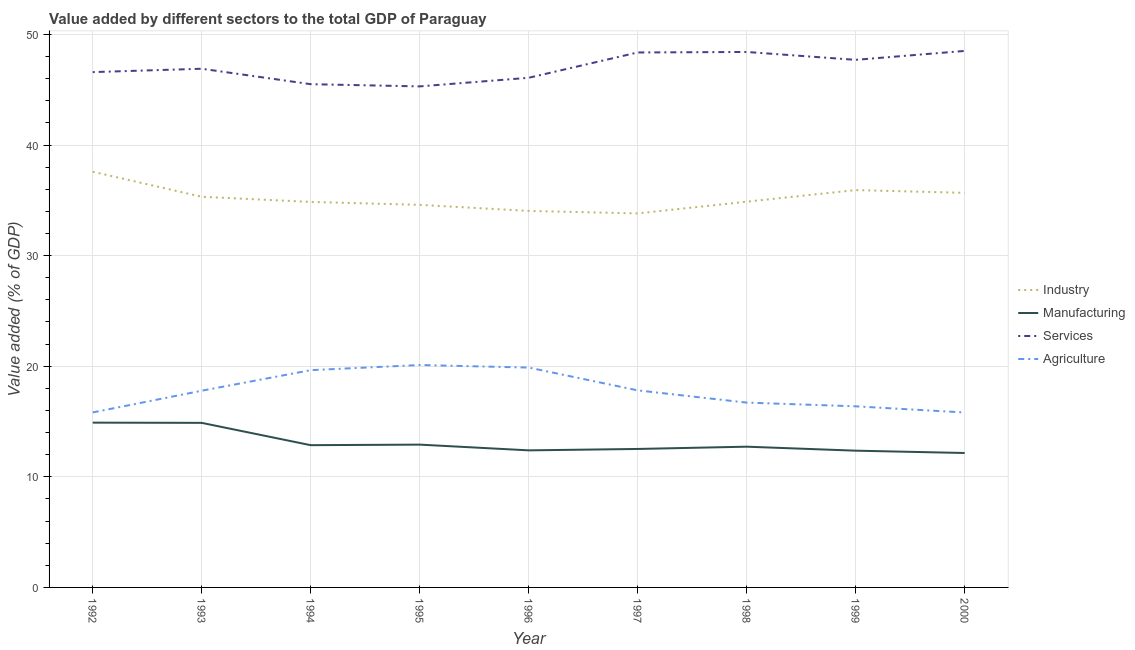How many different coloured lines are there?
Give a very brief answer. 4. What is the value added by manufacturing sector in 1997?
Your response must be concise. 12.52. Across all years, what is the maximum value added by industrial sector?
Offer a terse response. 37.59. Across all years, what is the minimum value added by agricultural sector?
Keep it short and to the point. 15.82. What is the total value added by industrial sector in the graph?
Keep it short and to the point. 316.69. What is the difference between the value added by services sector in 1992 and that in 1997?
Keep it short and to the point. -1.78. What is the difference between the value added by agricultural sector in 1998 and the value added by industrial sector in 1994?
Provide a short and direct response. -18.15. What is the average value added by industrial sector per year?
Ensure brevity in your answer.  35.19. In the year 1999, what is the difference between the value added by industrial sector and value added by agricultural sector?
Make the answer very short. 19.55. What is the ratio of the value added by manufacturing sector in 1992 to that in 1999?
Your answer should be compact. 1.21. Is the value added by services sector in 1992 less than that in 1996?
Offer a terse response. No. Is the difference between the value added by agricultural sector in 1993 and 1995 greater than the difference between the value added by industrial sector in 1993 and 1995?
Offer a very short reply. No. What is the difference between the highest and the second highest value added by industrial sector?
Give a very brief answer. 1.66. What is the difference between the highest and the lowest value added by industrial sector?
Keep it short and to the point. 3.77. Does the value added by manufacturing sector monotonically increase over the years?
Make the answer very short. No. Is the value added by services sector strictly greater than the value added by industrial sector over the years?
Keep it short and to the point. Yes. Is the value added by services sector strictly less than the value added by agricultural sector over the years?
Give a very brief answer. No. What is the difference between two consecutive major ticks on the Y-axis?
Your response must be concise. 10. Does the graph contain any zero values?
Your response must be concise. No. How many legend labels are there?
Provide a succinct answer. 4. What is the title of the graph?
Keep it short and to the point. Value added by different sectors to the total GDP of Paraguay. Does "Offering training" appear as one of the legend labels in the graph?
Keep it short and to the point. No. What is the label or title of the Y-axis?
Provide a succinct answer. Value added (% of GDP). What is the Value added (% of GDP) of Industry in 1992?
Offer a very short reply. 37.59. What is the Value added (% of GDP) of Manufacturing in 1992?
Offer a terse response. 14.9. What is the Value added (% of GDP) in Services in 1992?
Provide a short and direct response. 46.59. What is the Value added (% of GDP) in Agriculture in 1992?
Your answer should be compact. 15.82. What is the Value added (% of GDP) of Industry in 1993?
Provide a short and direct response. 35.32. What is the Value added (% of GDP) in Manufacturing in 1993?
Offer a very short reply. 14.88. What is the Value added (% of GDP) in Services in 1993?
Provide a short and direct response. 46.9. What is the Value added (% of GDP) in Agriculture in 1993?
Your response must be concise. 17.78. What is the Value added (% of GDP) of Industry in 1994?
Ensure brevity in your answer.  34.86. What is the Value added (% of GDP) in Manufacturing in 1994?
Provide a succinct answer. 12.86. What is the Value added (% of GDP) in Services in 1994?
Your answer should be very brief. 45.5. What is the Value added (% of GDP) in Agriculture in 1994?
Offer a very short reply. 19.64. What is the Value added (% of GDP) of Industry in 1995?
Ensure brevity in your answer.  34.59. What is the Value added (% of GDP) in Manufacturing in 1995?
Your response must be concise. 12.91. What is the Value added (% of GDP) in Services in 1995?
Provide a short and direct response. 45.3. What is the Value added (% of GDP) in Agriculture in 1995?
Your answer should be compact. 20.11. What is the Value added (% of GDP) of Industry in 1996?
Ensure brevity in your answer.  34.04. What is the Value added (% of GDP) of Manufacturing in 1996?
Your response must be concise. 12.39. What is the Value added (% of GDP) in Services in 1996?
Keep it short and to the point. 46.08. What is the Value added (% of GDP) in Agriculture in 1996?
Keep it short and to the point. 19.88. What is the Value added (% of GDP) of Industry in 1997?
Your answer should be compact. 33.82. What is the Value added (% of GDP) in Manufacturing in 1997?
Offer a very short reply. 12.52. What is the Value added (% of GDP) in Services in 1997?
Keep it short and to the point. 48.37. What is the Value added (% of GDP) of Agriculture in 1997?
Ensure brevity in your answer.  17.82. What is the Value added (% of GDP) in Industry in 1998?
Keep it short and to the point. 34.88. What is the Value added (% of GDP) of Manufacturing in 1998?
Your answer should be compact. 12.72. What is the Value added (% of GDP) of Services in 1998?
Provide a short and direct response. 48.41. What is the Value added (% of GDP) of Agriculture in 1998?
Your answer should be very brief. 16.71. What is the Value added (% of GDP) in Industry in 1999?
Provide a succinct answer. 35.93. What is the Value added (% of GDP) of Manufacturing in 1999?
Your response must be concise. 12.36. What is the Value added (% of GDP) in Services in 1999?
Your response must be concise. 47.7. What is the Value added (% of GDP) of Agriculture in 1999?
Provide a short and direct response. 16.37. What is the Value added (% of GDP) of Industry in 2000?
Offer a very short reply. 35.68. What is the Value added (% of GDP) of Manufacturing in 2000?
Offer a very short reply. 12.15. What is the Value added (% of GDP) in Services in 2000?
Provide a short and direct response. 48.51. What is the Value added (% of GDP) of Agriculture in 2000?
Your response must be concise. 15.82. Across all years, what is the maximum Value added (% of GDP) in Industry?
Your answer should be very brief. 37.59. Across all years, what is the maximum Value added (% of GDP) of Manufacturing?
Ensure brevity in your answer.  14.9. Across all years, what is the maximum Value added (% of GDP) in Services?
Provide a succinct answer. 48.51. Across all years, what is the maximum Value added (% of GDP) in Agriculture?
Make the answer very short. 20.11. Across all years, what is the minimum Value added (% of GDP) of Industry?
Provide a succinct answer. 33.82. Across all years, what is the minimum Value added (% of GDP) of Manufacturing?
Offer a very short reply. 12.15. Across all years, what is the minimum Value added (% of GDP) in Services?
Give a very brief answer. 45.3. Across all years, what is the minimum Value added (% of GDP) of Agriculture?
Keep it short and to the point. 15.82. What is the total Value added (% of GDP) of Industry in the graph?
Give a very brief answer. 316.69. What is the total Value added (% of GDP) in Manufacturing in the graph?
Keep it short and to the point. 117.71. What is the total Value added (% of GDP) of Services in the graph?
Keep it short and to the point. 423.35. What is the total Value added (% of GDP) of Agriculture in the graph?
Offer a very short reply. 159.96. What is the difference between the Value added (% of GDP) in Industry in 1992 and that in 1993?
Ensure brevity in your answer.  2.27. What is the difference between the Value added (% of GDP) of Manufacturing in 1992 and that in 1993?
Your answer should be very brief. 0.02. What is the difference between the Value added (% of GDP) in Services in 1992 and that in 1993?
Ensure brevity in your answer.  -0.3. What is the difference between the Value added (% of GDP) of Agriculture in 1992 and that in 1993?
Offer a very short reply. -1.96. What is the difference between the Value added (% of GDP) of Industry in 1992 and that in 1994?
Your answer should be very brief. 2.73. What is the difference between the Value added (% of GDP) in Manufacturing in 1992 and that in 1994?
Make the answer very short. 2.04. What is the difference between the Value added (% of GDP) in Services in 1992 and that in 1994?
Ensure brevity in your answer.  1.09. What is the difference between the Value added (% of GDP) in Agriculture in 1992 and that in 1994?
Give a very brief answer. -3.82. What is the difference between the Value added (% of GDP) in Industry in 1992 and that in 1995?
Your answer should be very brief. 3. What is the difference between the Value added (% of GDP) of Manufacturing in 1992 and that in 1995?
Offer a terse response. 1.99. What is the difference between the Value added (% of GDP) of Services in 1992 and that in 1995?
Ensure brevity in your answer.  1.29. What is the difference between the Value added (% of GDP) in Agriculture in 1992 and that in 1995?
Keep it short and to the point. -4.29. What is the difference between the Value added (% of GDP) of Industry in 1992 and that in 1996?
Your answer should be compact. 3.54. What is the difference between the Value added (% of GDP) in Manufacturing in 1992 and that in 1996?
Provide a short and direct response. 2.51. What is the difference between the Value added (% of GDP) in Services in 1992 and that in 1996?
Offer a terse response. 0.51. What is the difference between the Value added (% of GDP) in Agriculture in 1992 and that in 1996?
Your response must be concise. -4.06. What is the difference between the Value added (% of GDP) in Industry in 1992 and that in 1997?
Ensure brevity in your answer.  3.77. What is the difference between the Value added (% of GDP) in Manufacturing in 1992 and that in 1997?
Offer a very short reply. 2.38. What is the difference between the Value added (% of GDP) in Services in 1992 and that in 1997?
Provide a short and direct response. -1.78. What is the difference between the Value added (% of GDP) of Agriculture in 1992 and that in 1997?
Your response must be concise. -1.99. What is the difference between the Value added (% of GDP) of Industry in 1992 and that in 1998?
Offer a very short reply. 2.71. What is the difference between the Value added (% of GDP) in Manufacturing in 1992 and that in 1998?
Offer a very short reply. 2.18. What is the difference between the Value added (% of GDP) of Services in 1992 and that in 1998?
Keep it short and to the point. -1.82. What is the difference between the Value added (% of GDP) in Agriculture in 1992 and that in 1998?
Provide a short and direct response. -0.89. What is the difference between the Value added (% of GDP) of Industry in 1992 and that in 1999?
Offer a very short reply. 1.66. What is the difference between the Value added (% of GDP) of Manufacturing in 1992 and that in 1999?
Make the answer very short. 2.54. What is the difference between the Value added (% of GDP) in Services in 1992 and that in 1999?
Ensure brevity in your answer.  -1.11. What is the difference between the Value added (% of GDP) of Agriculture in 1992 and that in 1999?
Make the answer very short. -0.55. What is the difference between the Value added (% of GDP) in Industry in 1992 and that in 2000?
Offer a terse response. 1.91. What is the difference between the Value added (% of GDP) in Manufacturing in 1992 and that in 2000?
Your answer should be very brief. 2.75. What is the difference between the Value added (% of GDP) in Services in 1992 and that in 2000?
Your answer should be compact. -1.92. What is the difference between the Value added (% of GDP) of Agriculture in 1992 and that in 2000?
Make the answer very short. 0.01. What is the difference between the Value added (% of GDP) in Industry in 1993 and that in 1994?
Your answer should be compact. 0.46. What is the difference between the Value added (% of GDP) in Manufacturing in 1993 and that in 1994?
Provide a short and direct response. 2.02. What is the difference between the Value added (% of GDP) in Services in 1993 and that in 1994?
Your answer should be compact. 1.4. What is the difference between the Value added (% of GDP) in Agriculture in 1993 and that in 1994?
Make the answer very short. -1.86. What is the difference between the Value added (% of GDP) in Industry in 1993 and that in 1995?
Provide a succinct answer. 0.73. What is the difference between the Value added (% of GDP) of Manufacturing in 1993 and that in 1995?
Offer a very short reply. 1.97. What is the difference between the Value added (% of GDP) in Services in 1993 and that in 1995?
Offer a very short reply. 1.6. What is the difference between the Value added (% of GDP) of Agriculture in 1993 and that in 1995?
Your answer should be compact. -2.33. What is the difference between the Value added (% of GDP) in Industry in 1993 and that in 1996?
Your answer should be very brief. 1.28. What is the difference between the Value added (% of GDP) in Manufacturing in 1993 and that in 1996?
Offer a terse response. 2.49. What is the difference between the Value added (% of GDP) in Services in 1993 and that in 1996?
Offer a terse response. 0.82. What is the difference between the Value added (% of GDP) in Agriculture in 1993 and that in 1996?
Provide a short and direct response. -2.09. What is the difference between the Value added (% of GDP) of Industry in 1993 and that in 1997?
Offer a terse response. 1.5. What is the difference between the Value added (% of GDP) of Manufacturing in 1993 and that in 1997?
Your response must be concise. 2.36. What is the difference between the Value added (% of GDP) of Services in 1993 and that in 1997?
Offer a very short reply. -1.47. What is the difference between the Value added (% of GDP) in Agriculture in 1993 and that in 1997?
Offer a terse response. -0.03. What is the difference between the Value added (% of GDP) of Industry in 1993 and that in 1998?
Keep it short and to the point. 0.44. What is the difference between the Value added (% of GDP) in Manufacturing in 1993 and that in 1998?
Provide a short and direct response. 2.15. What is the difference between the Value added (% of GDP) of Services in 1993 and that in 1998?
Provide a succinct answer. -1.52. What is the difference between the Value added (% of GDP) of Agriculture in 1993 and that in 1998?
Give a very brief answer. 1.07. What is the difference between the Value added (% of GDP) in Industry in 1993 and that in 1999?
Keep it short and to the point. -0.61. What is the difference between the Value added (% of GDP) of Manufacturing in 1993 and that in 1999?
Keep it short and to the point. 2.51. What is the difference between the Value added (% of GDP) in Services in 1993 and that in 1999?
Give a very brief answer. -0.8. What is the difference between the Value added (% of GDP) in Agriculture in 1993 and that in 1999?
Your answer should be compact. 1.41. What is the difference between the Value added (% of GDP) in Industry in 1993 and that in 2000?
Your answer should be very brief. -0.36. What is the difference between the Value added (% of GDP) in Manufacturing in 1993 and that in 2000?
Your response must be concise. 2.73. What is the difference between the Value added (% of GDP) in Services in 1993 and that in 2000?
Provide a succinct answer. -1.61. What is the difference between the Value added (% of GDP) in Agriculture in 1993 and that in 2000?
Keep it short and to the point. 1.97. What is the difference between the Value added (% of GDP) in Industry in 1994 and that in 1995?
Give a very brief answer. 0.27. What is the difference between the Value added (% of GDP) of Services in 1994 and that in 1995?
Make the answer very short. 0.2. What is the difference between the Value added (% of GDP) in Agriculture in 1994 and that in 1995?
Provide a succinct answer. -0.47. What is the difference between the Value added (% of GDP) of Industry in 1994 and that in 1996?
Your answer should be compact. 0.81. What is the difference between the Value added (% of GDP) of Manufacturing in 1994 and that in 1996?
Your response must be concise. 0.47. What is the difference between the Value added (% of GDP) of Services in 1994 and that in 1996?
Give a very brief answer. -0.58. What is the difference between the Value added (% of GDP) in Agriculture in 1994 and that in 1996?
Offer a very short reply. -0.24. What is the difference between the Value added (% of GDP) in Industry in 1994 and that in 1997?
Make the answer very short. 1.04. What is the difference between the Value added (% of GDP) of Manufacturing in 1994 and that in 1997?
Provide a short and direct response. 0.34. What is the difference between the Value added (% of GDP) in Services in 1994 and that in 1997?
Offer a very short reply. -2.87. What is the difference between the Value added (% of GDP) of Agriculture in 1994 and that in 1997?
Ensure brevity in your answer.  1.83. What is the difference between the Value added (% of GDP) of Industry in 1994 and that in 1998?
Provide a short and direct response. -0.02. What is the difference between the Value added (% of GDP) of Manufacturing in 1994 and that in 1998?
Make the answer very short. 0.14. What is the difference between the Value added (% of GDP) of Services in 1994 and that in 1998?
Ensure brevity in your answer.  -2.91. What is the difference between the Value added (% of GDP) in Agriculture in 1994 and that in 1998?
Offer a very short reply. 2.93. What is the difference between the Value added (% of GDP) of Industry in 1994 and that in 1999?
Offer a terse response. -1.07. What is the difference between the Value added (% of GDP) in Manufacturing in 1994 and that in 1999?
Offer a very short reply. 0.5. What is the difference between the Value added (% of GDP) of Services in 1994 and that in 1999?
Offer a very short reply. -2.2. What is the difference between the Value added (% of GDP) in Agriculture in 1994 and that in 1999?
Your answer should be compact. 3.27. What is the difference between the Value added (% of GDP) in Industry in 1994 and that in 2000?
Your answer should be compact. -0.82. What is the difference between the Value added (% of GDP) in Manufacturing in 1994 and that in 2000?
Your answer should be compact. 0.71. What is the difference between the Value added (% of GDP) in Services in 1994 and that in 2000?
Your answer should be compact. -3.01. What is the difference between the Value added (% of GDP) of Agriculture in 1994 and that in 2000?
Keep it short and to the point. 3.83. What is the difference between the Value added (% of GDP) in Industry in 1995 and that in 1996?
Your answer should be very brief. 0.55. What is the difference between the Value added (% of GDP) in Manufacturing in 1995 and that in 1996?
Offer a terse response. 0.52. What is the difference between the Value added (% of GDP) of Services in 1995 and that in 1996?
Your answer should be compact. -0.78. What is the difference between the Value added (% of GDP) of Agriculture in 1995 and that in 1996?
Provide a short and direct response. 0.23. What is the difference between the Value added (% of GDP) in Industry in 1995 and that in 1997?
Your response must be concise. 0.78. What is the difference between the Value added (% of GDP) in Manufacturing in 1995 and that in 1997?
Your response must be concise. 0.39. What is the difference between the Value added (% of GDP) in Services in 1995 and that in 1997?
Provide a short and direct response. -3.07. What is the difference between the Value added (% of GDP) of Agriculture in 1995 and that in 1997?
Give a very brief answer. 2.29. What is the difference between the Value added (% of GDP) of Industry in 1995 and that in 1998?
Your answer should be compact. -0.29. What is the difference between the Value added (% of GDP) of Manufacturing in 1995 and that in 1998?
Your response must be concise. 0.19. What is the difference between the Value added (% of GDP) of Services in 1995 and that in 1998?
Provide a short and direct response. -3.11. What is the difference between the Value added (% of GDP) in Agriculture in 1995 and that in 1998?
Your answer should be compact. 3.4. What is the difference between the Value added (% of GDP) in Industry in 1995 and that in 1999?
Ensure brevity in your answer.  -1.33. What is the difference between the Value added (% of GDP) in Manufacturing in 1995 and that in 1999?
Make the answer very short. 0.55. What is the difference between the Value added (% of GDP) in Services in 1995 and that in 1999?
Provide a short and direct response. -2.4. What is the difference between the Value added (% of GDP) of Agriculture in 1995 and that in 1999?
Provide a short and direct response. 3.73. What is the difference between the Value added (% of GDP) of Industry in 1995 and that in 2000?
Your response must be concise. -1.09. What is the difference between the Value added (% of GDP) of Manufacturing in 1995 and that in 2000?
Keep it short and to the point. 0.76. What is the difference between the Value added (% of GDP) of Services in 1995 and that in 2000?
Your answer should be compact. -3.21. What is the difference between the Value added (% of GDP) of Agriculture in 1995 and that in 2000?
Your response must be concise. 4.29. What is the difference between the Value added (% of GDP) in Industry in 1996 and that in 1997?
Ensure brevity in your answer.  0.23. What is the difference between the Value added (% of GDP) in Manufacturing in 1996 and that in 1997?
Give a very brief answer. -0.13. What is the difference between the Value added (% of GDP) of Services in 1996 and that in 1997?
Provide a short and direct response. -2.29. What is the difference between the Value added (% of GDP) in Agriculture in 1996 and that in 1997?
Your answer should be compact. 2.06. What is the difference between the Value added (% of GDP) in Industry in 1996 and that in 1998?
Offer a terse response. -0.83. What is the difference between the Value added (% of GDP) of Manufacturing in 1996 and that in 1998?
Provide a succinct answer. -0.33. What is the difference between the Value added (% of GDP) of Services in 1996 and that in 1998?
Make the answer very short. -2.33. What is the difference between the Value added (% of GDP) of Agriculture in 1996 and that in 1998?
Your answer should be compact. 3.17. What is the difference between the Value added (% of GDP) in Industry in 1996 and that in 1999?
Make the answer very short. -1.88. What is the difference between the Value added (% of GDP) of Manufacturing in 1996 and that in 1999?
Ensure brevity in your answer.  0.03. What is the difference between the Value added (% of GDP) in Services in 1996 and that in 1999?
Keep it short and to the point. -1.62. What is the difference between the Value added (% of GDP) in Agriculture in 1996 and that in 1999?
Ensure brevity in your answer.  3.5. What is the difference between the Value added (% of GDP) in Industry in 1996 and that in 2000?
Your response must be concise. -1.64. What is the difference between the Value added (% of GDP) in Manufacturing in 1996 and that in 2000?
Offer a very short reply. 0.24. What is the difference between the Value added (% of GDP) of Services in 1996 and that in 2000?
Provide a short and direct response. -2.43. What is the difference between the Value added (% of GDP) of Agriculture in 1996 and that in 2000?
Give a very brief answer. 4.06. What is the difference between the Value added (% of GDP) in Industry in 1997 and that in 1998?
Ensure brevity in your answer.  -1.06. What is the difference between the Value added (% of GDP) of Manufacturing in 1997 and that in 1998?
Provide a succinct answer. -0.2. What is the difference between the Value added (% of GDP) of Services in 1997 and that in 1998?
Offer a very short reply. -0.05. What is the difference between the Value added (% of GDP) of Agriculture in 1997 and that in 1998?
Make the answer very short. 1.11. What is the difference between the Value added (% of GDP) in Industry in 1997 and that in 1999?
Offer a very short reply. -2.11. What is the difference between the Value added (% of GDP) of Manufacturing in 1997 and that in 1999?
Provide a succinct answer. 0.16. What is the difference between the Value added (% of GDP) of Services in 1997 and that in 1999?
Offer a terse response. 0.67. What is the difference between the Value added (% of GDP) in Agriculture in 1997 and that in 1999?
Your response must be concise. 1.44. What is the difference between the Value added (% of GDP) in Industry in 1997 and that in 2000?
Offer a very short reply. -1.86. What is the difference between the Value added (% of GDP) of Manufacturing in 1997 and that in 2000?
Your response must be concise. 0.37. What is the difference between the Value added (% of GDP) in Services in 1997 and that in 2000?
Keep it short and to the point. -0.14. What is the difference between the Value added (% of GDP) in Agriculture in 1997 and that in 2000?
Keep it short and to the point. 2. What is the difference between the Value added (% of GDP) in Industry in 1998 and that in 1999?
Your response must be concise. -1.05. What is the difference between the Value added (% of GDP) of Manufacturing in 1998 and that in 1999?
Your answer should be very brief. 0.36. What is the difference between the Value added (% of GDP) of Services in 1998 and that in 1999?
Provide a succinct answer. 0.71. What is the difference between the Value added (% of GDP) in Agriculture in 1998 and that in 1999?
Offer a terse response. 0.34. What is the difference between the Value added (% of GDP) in Industry in 1998 and that in 2000?
Your response must be concise. -0.8. What is the difference between the Value added (% of GDP) of Manufacturing in 1998 and that in 2000?
Provide a short and direct response. 0.57. What is the difference between the Value added (% of GDP) in Services in 1998 and that in 2000?
Keep it short and to the point. -0.09. What is the difference between the Value added (% of GDP) in Agriculture in 1998 and that in 2000?
Offer a terse response. 0.89. What is the difference between the Value added (% of GDP) in Industry in 1999 and that in 2000?
Offer a very short reply. 0.25. What is the difference between the Value added (% of GDP) of Manufacturing in 1999 and that in 2000?
Keep it short and to the point. 0.21. What is the difference between the Value added (% of GDP) in Services in 1999 and that in 2000?
Your response must be concise. -0.81. What is the difference between the Value added (% of GDP) in Agriculture in 1999 and that in 2000?
Your answer should be very brief. 0.56. What is the difference between the Value added (% of GDP) of Industry in 1992 and the Value added (% of GDP) of Manufacturing in 1993?
Your answer should be very brief. 22.71. What is the difference between the Value added (% of GDP) of Industry in 1992 and the Value added (% of GDP) of Services in 1993?
Give a very brief answer. -9.31. What is the difference between the Value added (% of GDP) of Industry in 1992 and the Value added (% of GDP) of Agriculture in 1993?
Your response must be concise. 19.8. What is the difference between the Value added (% of GDP) in Manufacturing in 1992 and the Value added (% of GDP) in Services in 1993?
Offer a terse response. -32. What is the difference between the Value added (% of GDP) in Manufacturing in 1992 and the Value added (% of GDP) in Agriculture in 1993?
Offer a terse response. -2.88. What is the difference between the Value added (% of GDP) in Services in 1992 and the Value added (% of GDP) in Agriculture in 1993?
Your answer should be compact. 28.81. What is the difference between the Value added (% of GDP) of Industry in 1992 and the Value added (% of GDP) of Manufacturing in 1994?
Keep it short and to the point. 24.72. What is the difference between the Value added (% of GDP) in Industry in 1992 and the Value added (% of GDP) in Services in 1994?
Your answer should be compact. -7.91. What is the difference between the Value added (% of GDP) of Industry in 1992 and the Value added (% of GDP) of Agriculture in 1994?
Offer a very short reply. 17.94. What is the difference between the Value added (% of GDP) in Manufacturing in 1992 and the Value added (% of GDP) in Services in 1994?
Your answer should be very brief. -30.6. What is the difference between the Value added (% of GDP) in Manufacturing in 1992 and the Value added (% of GDP) in Agriculture in 1994?
Ensure brevity in your answer.  -4.74. What is the difference between the Value added (% of GDP) in Services in 1992 and the Value added (% of GDP) in Agriculture in 1994?
Ensure brevity in your answer.  26.95. What is the difference between the Value added (% of GDP) in Industry in 1992 and the Value added (% of GDP) in Manufacturing in 1995?
Ensure brevity in your answer.  24.67. What is the difference between the Value added (% of GDP) in Industry in 1992 and the Value added (% of GDP) in Services in 1995?
Ensure brevity in your answer.  -7.71. What is the difference between the Value added (% of GDP) of Industry in 1992 and the Value added (% of GDP) of Agriculture in 1995?
Your answer should be compact. 17.48. What is the difference between the Value added (% of GDP) of Manufacturing in 1992 and the Value added (% of GDP) of Services in 1995?
Make the answer very short. -30.4. What is the difference between the Value added (% of GDP) of Manufacturing in 1992 and the Value added (% of GDP) of Agriculture in 1995?
Offer a terse response. -5.21. What is the difference between the Value added (% of GDP) of Services in 1992 and the Value added (% of GDP) of Agriculture in 1995?
Make the answer very short. 26.48. What is the difference between the Value added (% of GDP) of Industry in 1992 and the Value added (% of GDP) of Manufacturing in 1996?
Ensure brevity in your answer.  25.19. What is the difference between the Value added (% of GDP) in Industry in 1992 and the Value added (% of GDP) in Services in 1996?
Provide a succinct answer. -8.49. What is the difference between the Value added (% of GDP) of Industry in 1992 and the Value added (% of GDP) of Agriculture in 1996?
Provide a succinct answer. 17.71. What is the difference between the Value added (% of GDP) in Manufacturing in 1992 and the Value added (% of GDP) in Services in 1996?
Keep it short and to the point. -31.18. What is the difference between the Value added (% of GDP) of Manufacturing in 1992 and the Value added (% of GDP) of Agriculture in 1996?
Offer a terse response. -4.98. What is the difference between the Value added (% of GDP) of Services in 1992 and the Value added (% of GDP) of Agriculture in 1996?
Your response must be concise. 26.71. What is the difference between the Value added (% of GDP) of Industry in 1992 and the Value added (% of GDP) of Manufacturing in 1997?
Offer a very short reply. 25.07. What is the difference between the Value added (% of GDP) in Industry in 1992 and the Value added (% of GDP) in Services in 1997?
Your answer should be very brief. -10.78. What is the difference between the Value added (% of GDP) of Industry in 1992 and the Value added (% of GDP) of Agriculture in 1997?
Give a very brief answer. 19.77. What is the difference between the Value added (% of GDP) in Manufacturing in 1992 and the Value added (% of GDP) in Services in 1997?
Make the answer very short. -33.47. What is the difference between the Value added (% of GDP) of Manufacturing in 1992 and the Value added (% of GDP) of Agriculture in 1997?
Offer a terse response. -2.92. What is the difference between the Value added (% of GDP) in Services in 1992 and the Value added (% of GDP) in Agriculture in 1997?
Ensure brevity in your answer.  28.77. What is the difference between the Value added (% of GDP) of Industry in 1992 and the Value added (% of GDP) of Manufacturing in 1998?
Give a very brief answer. 24.86. What is the difference between the Value added (% of GDP) of Industry in 1992 and the Value added (% of GDP) of Services in 1998?
Ensure brevity in your answer.  -10.83. What is the difference between the Value added (% of GDP) in Industry in 1992 and the Value added (% of GDP) in Agriculture in 1998?
Keep it short and to the point. 20.88. What is the difference between the Value added (% of GDP) in Manufacturing in 1992 and the Value added (% of GDP) in Services in 1998?
Offer a terse response. -33.51. What is the difference between the Value added (% of GDP) of Manufacturing in 1992 and the Value added (% of GDP) of Agriculture in 1998?
Provide a short and direct response. -1.81. What is the difference between the Value added (% of GDP) of Services in 1992 and the Value added (% of GDP) of Agriculture in 1998?
Your answer should be compact. 29.88. What is the difference between the Value added (% of GDP) in Industry in 1992 and the Value added (% of GDP) in Manufacturing in 1999?
Make the answer very short. 25.22. What is the difference between the Value added (% of GDP) of Industry in 1992 and the Value added (% of GDP) of Services in 1999?
Offer a terse response. -10.11. What is the difference between the Value added (% of GDP) of Industry in 1992 and the Value added (% of GDP) of Agriculture in 1999?
Offer a very short reply. 21.21. What is the difference between the Value added (% of GDP) in Manufacturing in 1992 and the Value added (% of GDP) in Services in 1999?
Your response must be concise. -32.8. What is the difference between the Value added (% of GDP) of Manufacturing in 1992 and the Value added (% of GDP) of Agriculture in 1999?
Your answer should be very brief. -1.47. What is the difference between the Value added (% of GDP) in Services in 1992 and the Value added (% of GDP) in Agriculture in 1999?
Offer a terse response. 30.22. What is the difference between the Value added (% of GDP) of Industry in 1992 and the Value added (% of GDP) of Manufacturing in 2000?
Provide a short and direct response. 25.43. What is the difference between the Value added (% of GDP) of Industry in 1992 and the Value added (% of GDP) of Services in 2000?
Provide a short and direct response. -10.92. What is the difference between the Value added (% of GDP) of Industry in 1992 and the Value added (% of GDP) of Agriculture in 2000?
Provide a succinct answer. 21.77. What is the difference between the Value added (% of GDP) of Manufacturing in 1992 and the Value added (% of GDP) of Services in 2000?
Offer a very short reply. -33.61. What is the difference between the Value added (% of GDP) in Manufacturing in 1992 and the Value added (% of GDP) in Agriculture in 2000?
Provide a succinct answer. -0.92. What is the difference between the Value added (% of GDP) in Services in 1992 and the Value added (% of GDP) in Agriculture in 2000?
Make the answer very short. 30.78. What is the difference between the Value added (% of GDP) of Industry in 1993 and the Value added (% of GDP) of Manufacturing in 1994?
Make the answer very short. 22.46. What is the difference between the Value added (% of GDP) in Industry in 1993 and the Value added (% of GDP) in Services in 1994?
Offer a very short reply. -10.18. What is the difference between the Value added (% of GDP) in Industry in 1993 and the Value added (% of GDP) in Agriculture in 1994?
Give a very brief answer. 15.68. What is the difference between the Value added (% of GDP) in Manufacturing in 1993 and the Value added (% of GDP) in Services in 1994?
Offer a terse response. -30.62. What is the difference between the Value added (% of GDP) of Manufacturing in 1993 and the Value added (% of GDP) of Agriculture in 1994?
Make the answer very short. -4.76. What is the difference between the Value added (% of GDP) of Services in 1993 and the Value added (% of GDP) of Agriculture in 1994?
Provide a succinct answer. 27.25. What is the difference between the Value added (% of GDP) in Industry in 1993 and the Value added (% of GDP) in Manufacturing in 1995?
Keep it short and to the point. 22.41. What is the difference between the Value added (% of GDP) in Industry in 1993 and the Value added (% of GDP) in Services in 1995?
Your answer should be compact. -9.98. What is the difference between the Value added (% of GDP) of Industry in 1993 and the Value added (% of GDP) of Agriculture in 1995?
Offer a terse response. 15.21. What is the difference between the Value added (% of GDP) in Manufacturing in 1993 and the Value added (% of GDP) in Services in 1995?
Offer a terse response. -30.42. What is the difference between the Value added (% of GDP) of Manufacturing in 1993 and the Value added (% of GDP) of Agriculture in 1995?
Provide a short and direct response. -5.23. What is the difference between the Value added (% of GDP) in Services in 1993 and the Value added (% of GDP) in Agriculture in 1995?
Provide a succinct answer. 26.79. What is the difference between the Value added (% of GDP) in Industry in 1993 and the Value added (% of GDP) in Manufacturing in 1996?
Give a very brief answer. 22.93. What is the difference between the Value added (% of GDP) in Industry in 1993 and the Value added (% of GDP) in Services in 1996?
Your response must be concise. -10.76. What is the difference between the Value added (% of GDP) of Industry in 1993 and the Value added (% of GDP) of Agriculture in 1996?
Your answer should be compact. 15.44. What is the difference between the Value added (% of GDP) in Manufacturing in 1993 and the Value added (% of GDP) in Services in 1996?
Offer a very short reply. -31.2. What is the difference between the Value added (% of GDP) in Manufacturing in 1993 and the Value added (% of GDP) in Agriculture in 1996?
Offer a terse response. -5. What is the difference between the Value added (% of GDP) of Services in 1993 and the Value added (% of GDP) of Agriculture in 1996?
Provide a succinct answer. 27.02. What is the difference between the Value added (% of GDP) of Industry in 1993 and the Value added (% of GDP) of Manufacturing in 1997?
Your response must be concise. 22.8. What is the difference between the Value added (% of GDP) in Industry in 1993 and the Value added (% of GDP) in Services in 1997?
Provide a short and direct response. -13.05. What is the difference between the Value added (% of GDP) of Industry in 1993 and the Value added (% of GDP) of Agriculture in 1997?
Offer a very short reply. 17.5. What is the difference between the Value added (% of GDP) of Manufacturing in 1993 and the Value added (% of GDP) of Services in 1997?
Keep it short and to the point. -33.49. What is the difference between the Value added (% of GDP) of Manufacturing in 1993 and the Value added (% of GDP) of Agriculture in 1997?
Offer a terse response. -2.94. What is the difference between the Value added (% of GDP) in Services in 1993 and the Value added (% of GDP) in Agriculture in 1997?
Offer a terse response. 29.08. What is the difference between the Value added (% of GDP) of Industry in 1993 and the Value added (% of GDP) of Manufacturing in 1998?
Keep it short and to the point. 22.6. What is the difference between the Value added (% of GDP) of Industry in 1993 and the Value added (% of GDP) of Services in 1998?
Offer a terse response. -13.09. What is the difference between the Value added (% of GDP) in Industry in 1993 and the Value added (% of GDP) in Agriculture in 1998?
Your response must be concise. 18.61. What is the difference between the Value added (% of GDP) of Manufacturing in 1993 and the Value added (% of GDP) of Services in 1998?
Give a very brief answer. -33.53. What is the difference between the Value added (% of GDP) in Manufacturing in 1993 and the Value added (% of GDP) in Agriculture in 1998?
Your response must be concise. -1.83. What is the difference between the Value added (% of GDP) of Services in 1993 and the Value added (% of GDP) of Agriculture in 1998?
Offer a very short reply. 30.19. What is the difference between the Value added (% of GDP) in Industry in 1993 and the Value added (% of GDP) in Manufacturing in 1999?
Ensure brevity in your answer.  22.96. What is the difference between the Value added (% of GDP) in Industry in 1993 and the Value added (% of GDP) in Services in 1999?
Offer a terse response. -12.38. What is the difference between the Value added (% of GDP) in Industry in 1993 and the Value added (% of GDP) in Agriculture in 1999?
Offer a terse response. 18.95. What is the difference between the Value added (% of GDP) of Manufacturing in 1993 and the Value added (% of GDP) of Services in 1999?
Ensure brevity in your answer.  -32.82. What is the difference between the Value added (% of GDP) of Manufacturing in 1993 and the Value added (% of GDP) of Agriculture in 1999?
Make the answer very short. -1.5. What is the difference between the Value added (% of GDP) of Services in 1993 and the Value added (% of GDP) of Agriculture in 1999?
Your answer should be compact. 30.52. What is the difference between the Value added (% of GDP) of Industry in 1993 and the Value added (% of GDP) of Manufacturing in 2000?
Offer a terse response. 23.17. What is the difference between the Value added (% of GDP) of Industry in 1993 and the Value added (% of GDP) of Services in 2000?
Your answer should be compact. -13.19. What is the difference between the Value added (% of GDP) of Industry in 1993 and the Value added (% of GDP) of Agriculture in 2000?
Make the answer very short. 19.5. What is the difference between the Value added (% of GDP) in Manufacturing in 1993 and the Value added (% of GDP) in Services in 2000?
Keep it short and to the point. -33.63. What is the difference between the Value added (% of GDP) in Manufacturing in 1993 and the Value added (% of GDP) in Agriculture in 2000?
Keep it short and to the point. -0.94. What is the difference between the Value added (% of GDP) in Services in 1993 and the Value added (% of GDP) in Agriculture in 2000?
Your response must be concise. 31.08. What is the difference between the Value added (% of GDP) of Industry in 1994 and the Value added (% of GDP) of Manufacturing in 1995?
Offer a very short reply. 21.95. What is the difference between the Value added (% of GDP) of Industry in 1994 and the Value added (% of GDP) of Services in 1995?
Your answer should be very brief. -10.44. What is the difference between the Value added (% of GDP) in Industry in 1994 and the Value added (% of GDP) in Agriculture in 1995?
Your response must be concise. 14.75. What is the difference between the Value added (% of GDP) of Manufacturing in 1994 and the Value added (% of GDP) of Services in 1995?
Give a very brief answer. -32.44. What is the difference between the Value added (% of GDP) of Manufacturing in 1994 and the Value added (% of GDP) of Agriculture in 1995?
Your answer should be compact. -7.25. What is the difference between the Value added (% of GDP) in Services in 1994 and the Value added (% of GDP) in Agriculture in 1995?
Provide a short and direct response. 25.39. What is the difference between the Value added (% of GDP) in Industry in 1994 and the Value added (% of GDP) in Manufacturing in 1996?
Your response must be concise. 22.46. What is the difference between the Value added (% of GDP) of Industry in 1994 and the Value added (% of GDP) of Services in 1996?
Make the answer very short. -11.22. What is the difference between the Value added (% of GDP) in Industry in 1994 and the Value added (% of GDP) in Agriculture in 1996?
Provide a short and direct response. 14.98. What is the difference between the Value added (% of GDP) in Manufacturing in 1994 and the Value added (% of GDP) in Services in 1996?
Offer a terse response. -33.22. What is the difference between the Value added (% of GDP) of Manufacturing in 1994 and the Value added (% of GDP) of Agriculture in 1996?
Give a very brief answer. -7.02. What is the difference between the Value added (% of GDP) in Services in 1994 and the Value added (% of GDP) in Agriculture in 1996?
Your answer should be very brief. 25.62. What is the difference between the Value added (% of GDP) of Industry in 1994 and the Value added (% of GDP) of Manufacturing in 1997?
Make the answer very short. 22.34. What is the difference between the Value added (% of GDP) of Industry in 1994 and the Value added (% of GDP) of Services in 1997?
Your response must be concise. -13.51. What is the difference between the Value added (% of GDP) in Industry in 1994 and the Value added (% of GDP) in Agriculture in 1997?
Make the answer very short. 17.04. What is the difference between the Value added (% of GDP) in Manufacturing in 1994 and the Value added (% of GDP) in Services in 1997?
Provide a succinct answer. -35.51. What is the difference between the Value added (% of GDP) in Manufacturing in 1994 and the Value added (% of GDP) in Agriculture in 1997?
Your answer should be compact. -4.96. What is the difference between the Value added (% of GDP) of Services in 1994 and the Value added (% of GDP) of Agriculture in 1997?
Your answer should be compact. 27.68. What is the difference between the Value added (% of GDP) in Industry in 1994 and the Value added (% of GDP) in Manufacturing in 1998?
Give a very brief answer. 22.13. What is the difference between the Value added (% of GDP) in Industry in 1994 and the Value added (% of GDP) in Services in 1998?
Your answer should be compact. -13.56. What is the difference between the Value added (% of GDP) in Industry in 1994 and the Value added (% of GDP) in Agriculture in 1998?
Make the answer very short. 18.15. What is the difference between the Value added (% of GDP) in Manufacturing in 1994 and the Value added (% of GDP) in Services in 1998?
Your answer should be compact. -35.55. What is the difference between the Value added (% of GDP) in Manufacturing in 1994 and the Value added (% of GDP) in Agriculture in 1998?
Your answer should be compact. -3.85. What is the difference between the Value added (% of GDP) in Services in 1994 and the Value added (% of GDP) in Agriculture in 1998?
Offer a very short reply. 28.79. What is the difference between the Value added (% of GDP) in Industry in 1994 and the Value added (% of GDP) in Manufacturing in 1999?
Your answer should be compact. 22.49. What is the difference between the Value added (% of GDP) in Industry in 1994 and the Value added (% of GDP) in Services in 1999?
Your answer should be compact. -12.84. What is the difference between the Value added (% of GDP) of Industry in 1994 and the Value added (% of GDP) of Agriculture in 1999?
Offer a very short reply. 18.48. What is the difference between the Value added (% of GDP) of Manufacturing in 1994 and the Value added (% of GDP) of Services in 1999?
Your response must be concise. -34.84. What is the difference between the Value added (% of GDP) of Manufacturing in 1994 and the Value added (% of GDP) of Agriculture in 1999?
Your answer should be compact. -3.51. What is the difference between the Value added (% of GDP) of Services in 1994 and the Value added (% of GDP) of Agriculture in 1999?
Ensure brevity in your answer.  29.13. What is the difference between the Value added (% of GDP) of Industry in 1994 and the Value added (% of GDP) of Manufacturing in 2000?
Your answer should be very brief. 22.7. What is the difference between the Value added (% of GDP) in Industry in 1994 and the Value added (% of GDP) in Services in 2000?
Offer a terse response. -13.65. What is the difference between the Value added (% of GDP) of Industry in 1994 and the Value added (% of GDP) of Agriculture in 2000?
Your answer should be compact. 19.04. What is the difference between the Value added (% of GDP) of Manufacturing in 1994 and the Value added (% of GDP) of Services in 2000?
Offer a terse response. -35.65. What is the difference between the Value added (% of GDP) of Manufacturing in 1994 and the Value added (% of GDP) of Agriculture in 2000?
Keep it short and to the point. -2.95. What is the difference between the Value added (% of GDP) in Services in 1994 and the Value added (% of GDP) in Agriculture in 2000?
Your answer should be compact. 29.68. What is the difference between the Value added (% of GDP) of Industry in 1995 and the Value added (% of GDP) of Manufacturing in 1996?
Provide a short and direct response. 22.2. What is the difference between the Value added (% of GDP) of Industry in 1995 and the Value added (% of GDP) of Services in 1996?
Your response must be concise. -11.49. What is the difference between the Value added (% of GDP) of Industry in 1995 and the Value added (% of GDP) of Agriculture in 1996?
Ensure brevity in your answer.  14.71. What is the difference between the Value added (% of GDP) of Manufacturing in 1995 and the Value added (% of GDP) of Services in 1996?
Ensure brevity in your answer.  -33.17. What is the difference between the Value added (% of GDP) of Manufacturing in 1995 and the Value added (% of GDP) of Agriculture in 1996?
Your answer should be very brief. -6.97. What is the difference between the Value added (% of GDP) of Services in 1995 and the Value added (% of GDP) of Agriculture in 1996?
Provide a short and direct response. 25.42. What is the difference between the Value added (% of GDP) of Industry in 1995 and the Value added (% of GDP) of Manufacturing in 1997?
Give a very brief answer. 22.07. What is the difference between the Value added (% of GDP) in Industry in 1995 and the Value added (% of GDP) in Services in 1997?
Offer a terse response. -13.78. What is the difference between the Value added (% of GDP) of Industry in 1995 and the Value added (% of GDP) of Agriculture in 1997?
Your answer should be very brief. 16.77. What is the difference between the Value added (% of GDP) of Manufacturing in 1995 and the Value added (% of GDP) of Services in 1997?
Make the answer very short. -35.46. What is the difference between the Value added (% of GDP) in Manufacturing in 1995 and the Value added (% of GDP) in Agriculture in 1997?
Offer a terse response. -4.91. What is the difference between the Value added (% of GDP) in Services in 1995 and the Value added (% of GDP) in Agriculture in 1997?
Your answer should be very brief. 27.48. What is the difference between the Value added (% of GDP) of Industry in 1995 and the Value added (% of GDP) of Manufacturing in 1998?
Make the answer very short. 21.87. What is the difference between the Value added (% of GDP) in Industry in 1995 and the Value added (% of GDP) in Services in 1998?
Your answer should be very brief. -13.82. What is the difference between the Value added (% of GDP) of Industry in 1995 and the Value added (% of GDP) of Agriculture in 1998?
Provide a short and direct response. 17.88. What is the difference between the Value added (% of GDP) of Manufacturing in 1995 and the Value added (% of GDP) of Services in 1998?
Your answer should be very brief. -35.5. What is the difference between the Value added (% of GDP) in Manufacturing in 1995 and the Value added (% of GDP) in Agriculture in 1998?
Provide a short and direct response. -3.8. What is the difference between the Value added (% of GDP) in Services in 1995 and the Value added (% of GDP) in Agriculture in 1998?
Offer a very short reply. 28.59. What is the difference between the Value added (% of GDP) in Industry in 1995 and the Value added (% of GDP) in Manufacturing in 1999?
Make the answer very short. 22.23. What is the difference between the Value added (% of GDP) of Industry in 1995 and the Value added (% of GDP) of Services in 1999?
Give a very brief answer. -13.11. What is the difference between the Value added (% of GDP) in Industry in 1995 and the Value added (% of GDP) in Agriculture in 1999?
Your response must be concise. 18.22. What is the difference between the Value added (% of GDP) in Manufacturing in 1995 and the Value added (% of GDP) in Services in 1999?
Your answer should be very brief. -34.79. What is the difference between the Value added (% of GDP) of Manufacturing in 1995 and the Value added (% of GDP) of Agriculture in 1999?
Give a very brief answer. -3.46. What is the difference between the Value added (% of GDP) in Services in 1995 and the Value added (% of GDP) in Agriculture in 1999?
Give a very brief answer. 28.93. What is the difference between the Value added (% of GDP) in Industry in 1995 and the Value added (% of GDP) in Manufacturing in 2000?
Provide a short and direct response. 22.44. What is the difference between the Value added (% of GDP) in Industry in 1995 and the Value added (% of GDP) in Services in 2000?
Give a very brief answer. -13.92. What is the difference between the Value added (% of GDP) in Industry in 1995 and the Value added (% of GDP) in Agriculture in 2000?
Offer a very short reply. 18.77. What is the difference between the Value added (% of GDP) of Manufacturing in 1995 and the Value added (% of GDP) of Services in 2000?
Offer a very short reply. -35.6. What is the difference between the Value added (% of GDP) in Manufacturing in 1995 and the Value added (% of GDP) in Agriculture in 2000?
Ensure brevity in your answer.  -2.9. What is the difference between the Value added (% of GDP) in Services in 1995 and the Value added (% of GDP) in Agriculture in 2000?
Give a very brief answer. 29.48. What is the difference between the Value added (% of GDP) in Industry in 1996 and the Value added (% of GDP) in Manufacturing in 1997?
Provide a short and direct response. 21.52. What is the difference between the Value added (% of GDP) in Industry in 1996 and the Value added (% of GDP) in Services in 1997?
Offer a terse response. -14.32. What is the difference between the Value added (% of GDP) of Industry in 1996 and the Value added (% of GDP) of Agriculture in 1997?
Ensure brevity in your answer.  16.22. What is the difference between the Value added (% of GDP) in Manufacturing in 1996 and the Value added (% of GDP) in Services in 1997?
Give a very brief answer. -35.97. What is the difference between the Value added (% of GDP) in Manufacturing in 1996 and the Value added (% of GDP) in Agriculture in 1997?
Offer a very short reply. -5.42. What is the difference between the Value added (% of GDP) in Services in 1996 and the Value added (% of GDP) in Agriculture in 1997?
Your answer should be compact. 28.26. What is the difference between the Value added (% of GDP) of Industry in 1996 and the Value added (% of GDP) of Manufacturing in 1998?
Keep it short and to the point. 21.32. What is the difference between the Value added (% of GDP) in Industry in 1996 and the Value added (% of GDP) in Services in 1998?
Your response must be concise. -14.37. What is the difference between the Value added (% of GDP) in Industry in 1996 and the Value added (% of GDP) in Agriculture in 1998?
Make the answer very short. 17.33. What is the difference between the Value added (% of GDP) of Manufacturing in 1996 and the Value added (% of GDP) of Services in 1998?
Your answer should be very brief. -36.02. What is the difference between the Value added (% of GDP) in Manufacturing in 1996 and the Value added (% of GDP) in Agriculture in 1998?
Make the answer very short. -4.32. What is the difference between the Value added (% of GDP) of Services in 1996 and the Value added (% of GDP) of Agriculture in 1998?
Make the answer very short. 29.37. What is the difference between the Value added (% of GDP) of Industry in 1996 and the Value added (% of GDP) of Manufacturing in 1999?
Give a very brief answer. 21.68. What is the difference between the Value added (% of GDP) of Industry in 1996 and the Value added (% of GDP) of Services in 1999?
Your response must be concise. -13.66. What is the difference between the Value added (% of GDP) of Industry in 1996 and the Value added (% of GDP) of Agriculture in 1999?
Your response must be concise. 17.67. What is the difference between the Value added (% of GDP) of Manufacturing in 1996 and the Value added (% of GDP) of Services in 1999?
Ensure brevity in your answer.  -35.31. What is the difference between the Value added (% of GDP) in Manufacturing in 1996 and the Value added (% of GDP) in Agriculture in 1999?
Offer a very short reply. -3.98. What is the difference between the Value added (% of GDP) in Services in 1996 and the Value added (% of GDP) in Agriculture in 1999?
Offer a very short reply. 29.7. What is the difference between the Value added (% of GDP) in Industry in 1996 and the Value added (% of GDP) in Manufacturing in 2000?
Give a very brief answer. 21.89. What is the difference between the Value added (% of GDP) in Industry in 1996 and the Value added (% of GDP) in Services in 2000?
Your answer should be very brief. -14.46. What is the difference between the Value added (% of GDP) of Industry in 1996 and the Value added (% of GDP) of Agriculture in 2000?
Ensure brevity in your answer.  18.23. What is the difference between the Value added (% of GDP) of Manufacturing in 1996 and the Value added (% of GDP) of Services in 2000?
Your answer should be very brief. -36.11. What is the difference between the Value added (% of GDP) of Manufacturing in 1996 and the Value added (% of GDP) of Agriculture in 2000?
Your answer should be compact. -3.42. What is the difference between the Value added (% of GDP) in Services in 1996 and the Value added (% of GDP) in Agriculture in 2000?
Provide a short and direct response. 30.26. What is the difference between the Value added (% of GDP) of Industry in 1997 and the Value added (% of GDP) of Manufacturing in 1998?
Your response must be concise. 21.09. What is the difference between the Value added (% of GDP) in Industry in 1997 and the Value added (% of GDP) in Services in 1998?
Provide a succinct answer. -14.6. What is the difference between the Value added (% of GDP) of Industry in 1997 and the Value added (% of GDP) of Agriculture in 1998?
Provide a short and direct response. 17.11. What is the difference between the Value added (% of GDP) of Manufacturing in 1997 and the Value added (% of GDP) of Services in 1998?
Your answer should be very brief. -35.89. What is the difference between the Value added (% of GDP) of Manufacturing in 1997 and the Value added (% of GDP) of Agriculture in 1998?
Your answer should be very brief. -4.19. What is the difference between the Value added (% of GDP) of Services in 1997 and the Value added (% of GDP) of Agriculture in 1998?
Your response must be concise. 31.66. What is the difference between the Value added (% of GDP) of Industry in 1997 and the Value added (% of GDP) of Manufacturing in 1999?
Offer a terse response. 21.45. What is the difference between the Value added (% of GDP) of Industry in 1997 and the Value added (% of GDP) of Services in 1999?
Give a very brief answer. -13.88. What is the difference between the Value added (% of GDP) of Industry in 1997 and the Value added (% of GDP) of Agriculture in 1999?
Offer a terse response. 17.44. What is the difference between the Value added (% of GDP) in Manufacturing in 1997 and the Value added (% of GDP) in Services in 1999?
Your answer should be compact. -35.18. What is the difference between the Value added (% of GDP) of Manufacturing in 1997 and the Value added (% of GDP) of Agriculture in 1999?
Provide a succinct answer. -3.85. What is the difference between the Value added (% of GDP) of Services in 1997 and the Value added (% of GDP) of Agriculture in 1999?
Offer a terse response. 31.99. What is the difference between the Value added (% of GDP) in Industry in 1997 and the Value added (% of GDP) in Manufacturing in 2000?
Keep it short and to the point. 21.66. What is the difference between the Value added (% of GDP) in Industry in 1997 and the Value added (% of GDP) in Services in 2000?
Provide a succinct answer. -14.69. What is the difference between the Value added (% of GDP) in Industry in 1997 and the Value added (% of GDP) in Agriculture in 2000?
Provide a succinct answer. 18. What is the difference between the Value added (% of GDP) of Manufacturing in 1997 and the Value added (% of GDP) of Services in 2000?
Provide a short and direct response. -35.99. What is the difference between the Value added (% of GDP) in Manufacturing in 1997 and the Value added (% of GDP) in Agriculture in 2000?
Your response must be concise. -3.3. What is the difference between the Value added (% of GDP) in Services in 1997 and the Value added (% of GDP) in Agriculture in 2000?
Your answer should be very brief. 32.55. What is the difference between the Value added (% of GDP) in Industry in 1998 and the Value added (% of GDP) in Manufacturing in 1999?
Provide a short and direct response. 22.51. What is the difference between the Value added (% of GDP) of Industry in 1998 and the Value added (% of GDP) of Services in 1999?
Your answer should be very brief. -12.82. What is the difference between the Value added (% of GDP) in Industry in 1998 and the Value added (% of GDP) in Agriculture in 1999?
Make the answer very short. 18.5. What is the difference between the Value added (% of GDP) in Manufacturing in 1998 and the Value added (% of GDP) in Services in 1999?
Provide a succinct answer. -34.98. What is the difference between the Value added (% of GDP) in Manufacturing in 1998 and the Value added (% of GDP) in Agriculture in 1999?
Your answer should be compact. -3.65. What is the difference between the Value added (% of GDP) of Services in 1998 and the Value added (% of GDP) of Agriculture in 1999?
Offer a very short reply. 32.04. What is the difference between the Value added (% of GDP) of Industry in 1998 and the Value added (% of GDP) of Manufacturing in 2000?
Your answer should be very brief. 22.72. What is the difference between the Value added (% of GDP) of Industry in 1998 and the Value added (% of GDP) of Services in 2000?
Your response must be concise. -13.63. What is the difference between the Value added (% of GDP) of Industry in 1998 and the Value added (% of GDP) of Agriculture in 2000?
Provide a short and direct response. 19.06. What is the difference between the Value added (% of GDP) of Manufacturing in 1998 and the Value added (% of GDP) of Services in 2000?
Provide a short and direct response. -35.78. What is the difference between the Value added (% of GDP) of Manufacturing in 1998 and the Value added (% of GDP) of Agriculture in 2000?
Your answer should be compact. -3.09. What is the difference between the Value added (% of GDP) in Services in 1998 and the Value added (% of GDP) in Agriculture in 2000?
Provide a short and direct response. 32.6. What is the difference between the Value added (% of GDP) in Industry in 1999 and the Value added (% of GDP) in Manufacturing in 2000?
Your answer should be compact. 23.77. What is the difference between the Value added (% of GDP) of Industry in 1999 and the Value added (% of GDP) of Services in 2000?
Keep it short and to the point. -12.58. What is the difference between the Value added (% of GDP) in Industry in 1999 and the Value added (% of GDP) in Agriculture in 2000?
Offer a very short reply. 20.11. What is the difference between the Value added (% of GDP) of Manufacturing in 1999 and the Value added (% of GDP) of Services in 2000?
Make the answer very short. -36.14. What is the difference between the Value added (% of GDP) in Manufacturing in 1999 and the Value added (% of GDP) in Agriculture in 2000?
Ensure brevity in your answer.  -3.45. What is the difference between the Value added (% of GDP) in Services in 1999 and the Value added (% of GDP) in Agriculture in 2000?
Your response must be concise. 31.88. What is the average Value added (% of GDP) in Industry per year?
Your response must be concise. 35.19. What is the average Value added (% of GDP) in Manufacturing per year?
Ensure brevity in your answer.  13.08. What is the average Value added (% of GDP) of Services per year?
Give a very brief answer. 47.04. What is the average Value added (% of GDP) of Agriculture per year?
Ensure brevity in your answer.  17.77. In the year 1992, what is the difference between the Value added (% of GDP) in Industry and Value added (% of GDP) in Manufacturing?
Your answer should be compact. 22.69. In the year 1992, what is the difference between the Value added (% of GDP) in Industry and Value added (% of GDP) in Services?
Your response must be concise. -9.01. In the year 1992, what is the difference between the Value added (% of GDP) of Industry and Value added (% of GDP) of Agriculture?
Provide a short and direct response. 21.76. In the year 1992, what is the difference between the Value added (% of GDP) in Manufacturing and Value added (% of GDP) in Services?
Give a very brief answer. -31.69. In the year 1992, what is the difference between the Value added (% of GDP) in Manufacturing and Value added (% of GDP) in Agriculture?
Ensure brevity in your answer.  -0.92. In the year 1992, what is the difference between the Value added (% of GDP) in Services and Value added (% of GDP) in Agriculture?
Give a very brief answer. 30.77. In the year 1993, what is the difference between the Value added (% of GDP) in Industry and Value added (% of GDP) in Manufacturing?
Provide a short and direct response. 20.44. In the year 1993, what is the difference between the Value added (% of GDP) in Industry and Value added (% of GDP) in Services?
Provide a short and direct response. -11.58. In the year 1993, what is the difference between the Value added (% of GDP) in Industry and Value added (% of GDP) in Agriculture?
Ensure brevity in your answer.  17.54. In the year 1993, what is the difference between the Value added (% of GDP) of Manufacturing and Value added (% of GDP) of Services?
Give a very brief answer. -32.02. In the year 1993, what is the difference between the Value added (% of GDP) of Manufacturing and Value added (% of GDP) of Agriculture?
Provide a succinct answer. -2.91. In the year 1993, what is the difference between the Value added (% of GDP) of Services and Value added (% of GDP) of Agriculture?
Provide a succinct answer. 29.11. In the year 1994, what is the difference between the Value added (% of GDP) of Industry and Value added (% of GDP) of Manufacturing?
Your answer should be very brief. 22. In the year 1994, what is the difference between the Value added (% of GDP) in Industry and Value added (% of GDP) in Services?
Offer a very short reply. -10.64. In the year 1994, what is the difference between the Value added (% of GDP) in Industry and Value added (% of GDP) in Agriculture?
Offer a very short reply. 15.21. In the year 1994, what is the difference between the Value added (% of GDP) of Manufacturing and Value added (% of GDP) of Services?
Provide a short and direct response. -32.64. In the year 1994, what is the difference between the Value added (% of GDP) of Manufacturing and Value added (% of GDP) of Agriculture?
Make the answer very short. -6.78. In the year 1994, what is the difference between the Value added (% of GDP) of Services and Value added (% of GDP) of Agriculture?
Provide a short and direct response. 25.86. In the year 1995, what is the difference between the Value added (% of GDP) in Industry and Value added (% of GDP) in Manufacturing?
Provide a short and direct response. 21.68. In the year 1995, what is the difference between the Value added (% of GDP) of Industry and Value added (% of GDP) of Services?
Make the answer very short. -10.71. In the year 1995, what is the difference between the Value added (% of GDP) in Industry and Value added (% of GDP) in Agriculture?
Your answer should be compact. 14.48. In the year 1995, what is the difference between the Value added (% of GDP) of Manufacturing and Value added (% of GDP) of Services?
Keep it short and to the point. -32.39. In the year 1995, what is the difference between the Value added (% of GDP) in Manufacturing and Value added (% of GDP) in Agriculture?
Your response must be concise. -7.2. In the year 1995, what is the difference between the Value added (% of GDP) in Services and Value added (% of GDP) in Agriculture?
Make the answer very short. 25.19. In the year 1996, what is the difference between the Value added (% of GDP) in Industry and Value added (% of GDP) in Manufacturing?
Offer a very short reply. 21.65. In the year 1996, what is the difference between the Value added (% of GDP) in Industry and Value added (% of GDP) in Services?
Your response must be concise. -12.04. In the year 1996, what is the difference between the Value added (% of GDP) of Industry and Value added (% of GDP) of Agriculture?
Keep it short and to the point. 14.16. In the year 1996, what is the difference between the Value added (% of GDP) in Manufacturing and Value added (% of GDP) in Services?
Make the answer very short. -33.69. In the year 1996, what is the difference between the Value added (% of GDP) of Manufacturing and Value added (% of GDP) of Agriculture?
Your answer should be very brief. -7.49. In the year 1996, what is the difference between the Value added (% of GDP) in Services and Value added (% of GDP) in Agriculture?
Provide a succinct answer. 26.2. In the year 1997, what is the difference between the Value added (% of GDP) in Industry and Value added (% of GDP) in Manufacturing?
Give a very brief answer. 21.3. In the year 1997, what is the difference between the Value added (% of GDP) of Industry and Value added (% of GDP) of Services?
Ensure brevity in your answer.  -14.55. In the year 1997, what is the difference between the Value added (% of GDP) of Industry and Value added (% of GDP) of Agriculture?
Offer a very short reply. 16. In the year 1997, what is the difference between the Value added (% of GDP) in Manufacturing and Value added (% of GDP) in Services?
Your answer should be very brief. -35.85. In the year 1997, what is the difference between the Value added (% of GDP) in Manufacturing and Value added (% of GDP) in Agriculture?
Make the answer very short. -5.3. In the year 1997, what is the difference between the Value added (% of GDP) in Services and Value added (% of GDP) in Agriculture?
Your answer should be compact. 30.55. In the year 1998, what is the difference between the Value added (% of GDP) in Industry and Value added (% of GDP) in Manufacturing?
Offer a terse response. 22.15. In the year 1998, what is the difference between the Value added (% of GDP) in Industry and Value added (% of GDP) in Services?
Offer a terse response. -13.54. In the year 1998, what is the difference between the Value added (% of GDP) of Industry and Value added (% of GDP) of Agriculture?
Ensure brevity in your answer.  18.17. In the year 1998, what is the difference between the Value added (% of GDP) in Manufacturing and Value added (% of GDP) in Services?
Offer a very short reply. -35.69. In the year 1998, what is the difference between the Value added (% of GDP) in Manufacturing and Value added (% of GDP) in Agriculture?
Provide a succinct answer. -3.99. In the year 1998, what is the difference between the Value added (% of GDP) of Services and Value added (% of GDP) of Agriculture?
Give a very brief answer. 31.7. In the year 1999, what is the difference between the Value added (% of GDP) in Industry and Value added (% of GDP) in Manufacturing?
Ensure brevity in your answer.  23.56. In the year 1999, what is the difference between the Value added (% of GDP) in Industry and Value added (% of GDP) in Services?
Make the answer very short. -11.78. In the year 1999, what is the difference between the Value added (% of GDP) in Industry and Value added (% of GDP) in Agriculture?
Keep it short and to the point. 19.55. In the year 1999, what is the difference between the Value added (% of GDP) of Manufacturing and Value added (% of GDP) of Services?
Provide a succinct answer. -35.34. In the year 1999, what is the difference between the Value added (% of GDP) in Manufacturing and Value added (% of GDP) in Agriculture?
Offer a terse response. -4.01. In the year 1999, what is the difference between the Value added (% of GDP) of Services and Value added (% of GDP) of Agriculture?
Your response must be concise. 31.33. In the year 2000, what is the difference between the Value added (% of GDP) in Industry and Value added (% of GDP) in Manufacturing?
Offer a terse response. 23.52. In the year 2000, what is the difference between the Value added (% of GDP) in Industry and Value added (% of GDP) in Services?
Your answer should be very brief. -12.83. In the year 2000, what is the difference between the Value added (% of GDP) of Industry and Value added (% of GDP) of Agriculture?
Give a very brief answer. 19.86. In the year 2000, what is the difference between the Value added (% of GDP) of Manufacturing and Value added (% of GDP) of Services?
Make the answer very short. -36.35. In the year 2000, what is the difference between the Value added (% of GDP) of Manufacturing and Value added (% of GDP) of Agriculture?
Your answer should be very brief. -3.66. In the year 2000, what is the difference between the Value added (% of GDP) of Services and Value added (% of GDP) of Agriculture?
Ensure brevity in your answer.  32.69. What is the ratio of the Value added (% of GDP) in Industry in 1992 to that in 1993?
Keep it short and to the point. 1.06. What is the ratio of the Value added (% of GDP) of Manufacturing in 1992 to that in 1993?
Your answer should be compact. 1. What is the ratio of the Value added (% of GDP) of Services in 1992 to that in 1993?
Give a very brief answer. 0.99. What is the ratio of the Value added (% of GDP) of Agriculture in 1992 to that in 1993?
Keep it short and to the point. 0.89. What is the ratio of the Value added (% of GDP) in Industry in 1992 to that in 1994?
Offer a terse response. 1.08. What is the ratio of the Value added (% of GDP) of Manufacturing in 1992 to that in 1994?
Your answer should be very brief. 1.16. What is the ratio of the Value added (% of GDP) of Agriculture in 1992 to that in 1994?
Provide a short and direct response. 0.81. What is the ratio of the Value added (% of GDP) of Industry in 1992 to that in 1995?
Your answer should be very brief. 1.09. What is the ratio of the Value added (% of GDP) in Manufacturing in 1992 to that in 1995?
Keep it short and to the point. 1.15. What is the ratio of the Value added (% of GDP) in Services in 1992 to that in 1995?
Keep it short and to the point. 1.03. What is the ratio of the Value added (% of GDP) in Agriculture in 1992 to that in 1995?
Ensure brevity in your answer.  0.79. What is the ratio of the Value added (% of GDP) in Industry in 1992 to that in 1996?
Provide a succinct answer. 1.1. What is the ratio of the Value added (% of GDP) in Manufacturing in 1992 to that in 1996?
Offer a very short reply. 1.2. What is the ratio of the Value added (% of GDP) of Services in 1992 to that in 1996?
Your response must be concise. 1.01. What is the ratio of the Value added (% of GDP) in Agriculture in 1992 to that in 1996?
Your answer should be compact. 0.8. What is the ratio of the Value added (% of GDP) in Industry in 1992 to that in 1997?
Give a very brief answer. 1.11. What is the ratio of the Value added (% of GDP) in Manufacturing in 1992 to that in 1997?
Provide a short and direct response. 1.19. What is the ratio of the Value added (% of GDP) of Services in 1992 to that in 1997?
Make the answer very short. 0.96. What is the ratio of the Value added (% of GDP) of Agriculture in 1992 to that in 1997?
Your response must be concise. 0.89. What is the ratio of the Value added (% of GDP) of Industry in 1992 to that in 1998?
Make the answer very short. 1.08. What is the ratio of the Value added (% of GDP) of Manufacturing in 1992 to that in 1998?
Keep it short and to the point. 1.17. What is the ratio of the Value added (% of GDP) in Services in 1992 to that in 1998?
Your answer should be very brief. 0.96. What is the ratio of the Value added (% of GDP) in Agriculture in 1992 to that in 1998?
Your answer should be very brief. 0.95. What is the ratio of the Value added (% of GDP) of Industry in 1992 to that in 1999?
Offer a terse response. 1.05. What is the ratio of the Value added (% of GDP) in Manufacturing in 1992 to that in 1999?
Give a very brief answer. 1.21. What is the ratio of the Value added (% of GDP) in Services in 1992 to that in 1999?
Give a very brief answer. 0.98. What is the ratio of the Value added (% of GDP) in Agriculture in 1992 to that in 1999?
Offer a very short reply. 0.97. What is the ratio of the Value added (% of GDP) of Industry in 1992 to that in 2000?
Offer a very short reply. 1.05. What is the ratio of the Value added (% of GDP) of Manufacturing in 1992 to that in 2000?
Offer a very short reply. 1.23. What is the ratio of the Value added (% of GDP) of Services in 1992 to that in 2000?
Your answer should be compact. 0.96. What is the ratio of the Value added (% of GDP) of Agriculture in 1992 to that in 2000?
Offer a very short reply. 1. What is the ratio of the Value added (% of GDP) in Industry in 1993 to that in 1994?
Ensure brevity in your answer.  1.01. What is the ratio of the Value added (% of GDP) in Manufacturing in 1993 to that in 1994?
Your response must be concise. 1.16. What is the ratio of the Value added (% of GDP) in Services in 1993 to that in 1994?
Your answer should be very brief. 1.03. What is the ratio of the Value added (% of GDP) of Agriculture in 1993 to that in 1994?
Give a very brief answer. 0.91. What is the ratio of the Value added (% of GDP) of Industry in 1993 to that in 1995?
Give a very brief answer. 1.02. What is the ratio of the Value added (% of GDP) of Manufacturing in 1993 to that in 1995?
Keep it short and to the point. 1.15. What is the ratio of the Value added (% of GDP) of Services in 1993 to that in 1995?
Give a very brief answer. 1.04. What is the ratio of the Value added (% of GDP) in Agriculture in 1993 to that in 1995?
Your answer should be compact. 0.88. What is the ratio of the Value added (% of GDP) of Industry in 1993 to that in 1996?
Your answer should be compact. 1.04. What is the ratio of the Value added (% of GDP) in Manufacturing in 1993 to that in 1996?
Your answer should be compact. 1.2. What is the ratio of the Value added (% of GDP) in Services in 1993 to that in 1996?
Offer a very short reply. 1.02. What is the ratio of the Value added (% of GDP) of Agriculture in 1993 to that in 1996?
Ensure brevity in your answer.  0.89. What is the ratio of the Value added (% of GDP) in Industry in 1993 to that in 1997?
Provide a succinct answer. 1.04. What is the ratio of the Value added (% of GDP) in Manufacturing in 1993 to that in 1997?
Keep it short and to the point. 1.19. What is the ratio of the Value added (% of GDP) in Services in 1993 to that in 1997?
Your answer should be very brief. 0.97. What is the ratio of the Value added (% of GDP) of Industry in 1993 to that in 1998?
Your answer should be very brief. 1.01. What is the ratio of the Value added (% of GDP) in Manufacturing in 1993 to that in 1998?
Your answer should be compact. 1.17. What is the ratio of the Value added (% of GDP) of Services in 1993 to that in 1998?
Your answer should be compact. 0.97. What is the ratio of the Value added (% of GDP) in Agriculture in 1993 to that in 1998?
Your answer should be compact. 1.06. What is the ratio of the Value added (% of GDP) of Industry in 1993 to that in 1999?
Ensure brevity in your answer.  0.98. What is the ratio of the Value added (% of GDP) of Manufacturing in 1993 to that in 1999?
Keep it short and to the point. 1.2. What is the ratio of the Value added (% of GDP) in Services in 1993 to that in 1999?
Keep it short and to the point. 0.98. What is the ratio of the Value added (% of GDP) of Agriculture in 1993 to that in 1999?
Ensure brevity in your answer.  1.09. What is the ratio of the Value added (% of GDP) of Industry in 1993 to that in 2000?
Give a very brief answer. 0.99. What is the ratio of the Value added (% of GDP) of Manufacturing in 1993 to that in 2000?
Ensure brevity in your answer.  1.22. What is the ratio of the Value added (% of GDP) in Services in 1993 to that in 2000?
Your answer should be compact. 0.97. What is the ratio of the Value added (% of GDP) in Agriculture in 1993 to that in 2000?
Your answer should be very brief. 1.12. What is the ratio of the Value added (% of GDP) in Industry in 1994 to that in 1995?
Give a very brief answer. 1.01. What is the ratio of the Value added (% of GDP) in Manufacturing in 1994 to that in 1995?
Make the answer very short. 1. What is the ratio of the Value added (% of GDP) in Services in 1994 to that in 1995?
Offer a very short reply. 1. What is the ratio of the Value added (% of GDP) of Agriculture in 1994 to that in 1995?
Your response must be concise. 0.98. What is the ratio of the Value added (% of GDP) in Industry in 1994 to that in 1996?
Ensure brevity in your answer.  1.02. What is the ratio of the Value added (% of GDP) in Manufacturing in 1994 to that in 1996?
Keep it short and to the point. 1.04. What is the ratio of the Value added (% of GDP) in Services in 1994 to that in 1996?
Provide a short and direct response. 0.99. What is the ratio of the Value added (% of GDP) of Industry in 1994 to that in 1997?
Your answer should be very brief. 1.03. What is the ratio of the Value added (% of GDP) of Manufacturing in 1994 to that in 1997?
Make the answer very short. 1.03. What is the ratio of the Value added (% of GDP) in Services in 1994 to that in 1997?
Your answer should be very brief. 0.94. What is the ratio of the Value added (% of GDP) of Agriculture in 1994 to that in 1997?
Your answer should be very brief. 1.1. What is the ratio of the Value added (% of GDP) of Manufacturing in 1994 to that in 1998?
Your answer should be very brief. 1.01. What is the ratio of the Value added (% of GDP) in Services in 1994 to that in 1998?
Your response must be concise. 0.94. What is the ratio of the Value added (% of GDP) in Agriculture in 1994 to that in 1998?
Provide a succinct answer. 1.18. What is the ratio of the Value added (% of GDP) in Industry in 1994 to that in 1999?
Your answer should be compact. 0.97. What is the ratio of the Value added (% of GDP) in Manufacturing in 1994 to that in 1999?
Offer a terse response. 1.04. What is the ratio of the Value added (% of GDP) of Services in 1994 to that in 1999?
Keep it short and to the point. 0.95. What is the ratio of the Value added (% of GDP) in Agriculture in 1994 to that in 1999?
Offer a very short reply. 1.2. What is the ratio of the Value added (% of GDP) in Industry in 1994 to that in 2000?
Your answer should be compact. 0.98. What is the ratio of the Value added (% of GDP) of Manufacturing in 1994 to that in 2000?
Offer a terse response. 1.06. What is the ratio of the Value added (% of GDP) of Services in 1994 to that in 2000?
Give a very brief answer. 0.94. What is the ratio of the Value added (% of GDP) of Agriculture in 1994 to that in 2000?
Your response must be concise. 1.24. What is the ratio of the Value added (% of GDP) of Industry in 1995 to that in 1996?
Keep it short and to the point. 1.02. What is the ratio of the Value added (% of GDP) in Manufacturing in 1995 to that in 1996?
Ensure brevity in your answer.  1.04. What is the ratio of the Value added (% of GDP) of Services in 1995 to that in 1996?
Keep it short and to the point. 0.98. What is the ratio of the Value added (% of GDP) in Agriculture in 1995 to that in 1996?
Offer a terse response. 1.01. What is the ratio of the Value added (% of GDP) of Industry in 1995 to that in 1997?
Offer a very short reply. 1.02. What is the ratio of the Value added (% of GDP) of Manufacturing in 1995 to that in 1997?
Offer a terse response. 1.03. What is the ratio of the Value added (% of GDP) in Services in 1995 to that in 1997?
Provide a short and direct response. 0.94. What is the ratio of the Value added (% of GDP) in Agriculture in 1995 to that in 1997?
Offer a very short reply. 1.13. What is the ratio of the Value added (% of GDP) in Industry in 1995 to that in 1998?
Provide a short and direct response. 0.99. What is the ratio of the Value added (% of GDP) in Manufacturing in 1995 to that in 1998?
Offer a terse response. 1.01. What is the ratio of the Value added (% of GDP) in Services in 1995 to that in 1998?
Provide a succinct answer. 0.94. What is the ratio of the Value added (% of GDP) in Agriculture in 1995 to that in 1998?
Offer a very short reply. 1.2. What is the ratio of the Value added (% of GDP) of Industry in 1995 to that in 1999?
Ensure brevity in your answer.  0.96. What is the ratio of the Value added (% of GDP) in Manufacturing in 1995 to that in 1999?
Provide a short and direct response. 1.04. What is the ratio of the Value added (% of GDP) of Services in 1995 to that in 1999?
Provide a succinct answer. 0.95. What is the ratio of the Value added (% of GDP) in Agriculture in 1995 to that in 1999?
Provide a succinct answer. 1.23. What is the ratio of the Value added (% of GDP) in Industry in 1995 to that in 2000?
Your answer should be compact. 0.97. What is the ratio of the Value added (% of GDP) of Manufacturing in 1995 to that in 2000?
Keep it short and to the point. 1.06. What is the ratio of the Value added (% of GDP) of Services in 1995 to that in 2000?
Keep it short and to the point. 0.93. What is the ratio of the Value added (% of GDP) of Agriculture in 1995 to that in 2000?
Give a very brief answer. 1.27. What is the ratio of the Value added (% of GDP) of Services in 1996 to that in 1997?
Your response must be concise. 0.95. What is the ratio of the Value added (% of GDP) of Agriculture in 1996 to that in 1997?
Make the answer very short. 1.12. What is the ratio of the Value added (% of GDP) of Industry in 1996 to that in 1998?
Your answer should be compact. 0.98. What is the ratio of the Value added (% of GDP) in Manufacturing in 1996 to that in 1998?
Give a very brief answer. 0.97. What is the ratio of the Value added (% of GDP) in Services in 1996 to that in 1998?
Offer a terse response. 0.95. What is the ratio of the Value added (% of GDP) in Agriculture in 1996 to that in 1998?
Keep it short and to the point. 1.19. What is the ratio of the Value added (% of GDP) in Industry in 1996 to that in 1999?
Offer a terse response. 0.95. What is the ratio of the Value added (% of GDP) in Manufacturing in 1996 to that in 1999?
Provide a succinct answer. 1. What is the ratio of the Value added (% of GDP) in Agriculture in 1996 to that in 1999?
Ensure brevity in your answer.  1.21. What is the ratio of the Value added (% of GDP) in Industry in 1996 to that in 2000?
Offer a very short reply. 0.95. What is the ratio of the Value added (% of GDP) of Manufacturing in 1996 to that in 2000?
Offer a very short reply. 1.02. What is the ratio of the Value added (% of GDP) of Services in 1996 to that in 2000?
Your answer should be very brief. 0.95. What is the ratio of the Value added (% of GDP) in Agriculture in 1996 to that in 2000?
Ensure brevity in your answer.  1.26. What is the ratio of the Value added (% of GDP) in Industry in 1997 to that in 1998?
Your answer should be compact. 0.97. What is the ratio of the Value added (% of GDP) of Agriculture in 1997 to that in 1998?
Give a very brief answer. 1.07. What is the ratio of the Value added (% of GDP) in Industry in 1997 to that in 1999?
Offer a terse response. 0.94. What is the ratio of the Value added (% of GDP) of Manufacturing in 1997 to that in 1999?
Make the answer very short. 1.01. What is the ratio of the Value added (% of GDP) of Agriculture in 1997 to that in 1999?
Keep it short and to the point. 1.09. What is the ratio of the Value added (% of GDP) in Industry in 1997 to that in 2000?
Give a very brief answer. 0.95. What is the ratio of the Value added (% of GDP) in Manufacturing in 1997 to that in 2000?
Keep it short and to the point. 1.03. What is the ratio of the Value added (% of GDP) of Services in 1997 to that in 2000?
Your answer should be compact. 1. What is the ratio of the Value added (% of GDP) of Agriculture in 1997 to that in 2000?
Keep it short and to the point. 1.13. What is the ratio of the Value added (% of GDP) in Industry in 1998 to that in 1999?
Your answer should be compact. 0.97. What is the ratio of the Value added (% of GDP) of Manufacturing in 1998 to that in 1999?
Your answer should be compact. 1.03. What is the ratio of the Value added (% of GDP) in Services in 1998 to that in 1999?
Your response must be concise. 1.01. What is the ratio of the Value added (% of GDP) of Agriculture in 1998 to that in 1999?
Make the answer very short. 1.02. What is the ratio of the Value added (% of GDP) in Industry in 1998 to that in 2000?
Your response must be concise. 0.98. What is the ratio of the Value added (% of GDP) of Manufacturing in 1998 to that in 2000?
Offer a terse response. 1.05. What is the ratio of the Value added (% of GDP) of Services in 1998 to that in 2000?
Make the answer very short. 1. What is the ratio of the Value added (% of GDP) of Agriculture in 1998 to that in 2000?
Keep it short and to the point. 1.06. What is the ratio of the Value added (% of GDP) of Manufacturing in 1999 to that in 2000?
Make the answer very short. 1.02. What is the ratio of the Value added (% of GDP) in Services in 1999 to that in 2000?
Provide a succinct answer. 0.98. What is the ratio of the Value added (% of GDP) in Agriculture in 1999 to that in 2000?
Offer a terse response. 1.04. What is the difference between the highest and the second highest Value added (% of GDP) in Industry?
Ensure brevity in your answer.  1.66. What is the difference between the highest and the second highest Value added (% of GDP) in Manufacturing?
Offer a terse response. 0.02. What is the difference between the highest and the second highest Value added (% of GDP) in Services?
Provide a succinct answer. 0.09. What is the difference between the highest and the second highest Value added (% of GDP) in Agriculture?
Provide a succinct answer. 0.23. What is the difference between the highest and the lowest Value added (% of GDP) of Industry?
Offer a very short reply. 3.77. What is the difference between the highest and the lowest Value added (% of GDP) in Manufacturing?
Your response must be concise. 2.75. What is the difference between the highest and the lowest Value added (% of GDP) of Services?
Your answer should be very brief. 3.21. What is the difference between the highest and the lowest Value added (% of GDP) in Agriculture?
Ensure brevity in your answer.  4.29. 